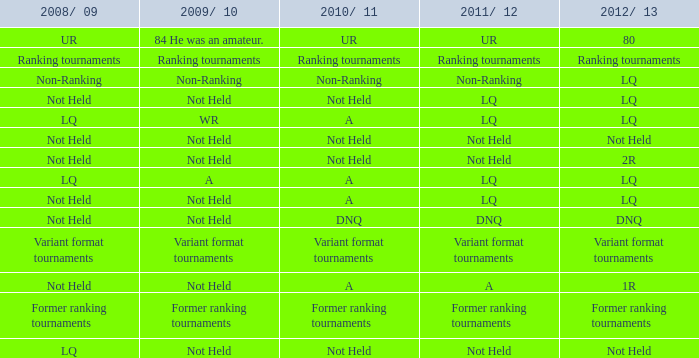When 2011/12 is not ranked, what would be the status of 2009/10? Non-Ranking. 